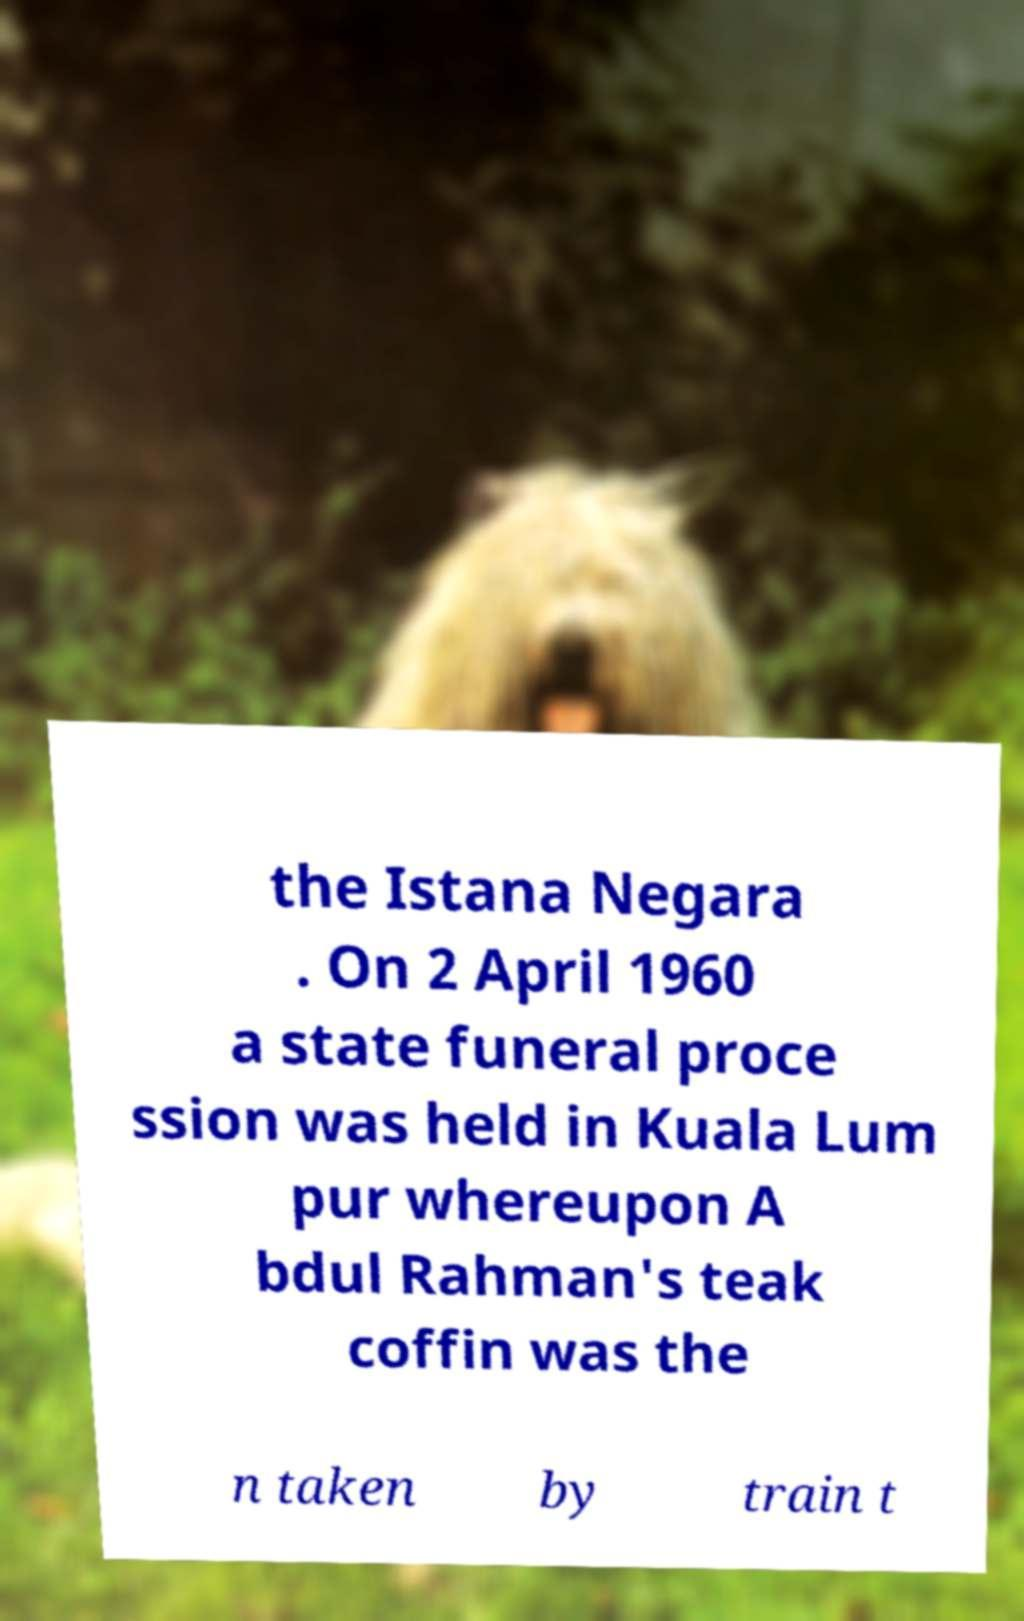Please identify and transcribe the text found in this image. the Istana Negara . On 2 April 1960 a state funeral proce ssion was held in Kuala Lum pur whereupon A bdul Rahman's teak coffin was the n taken by train t 